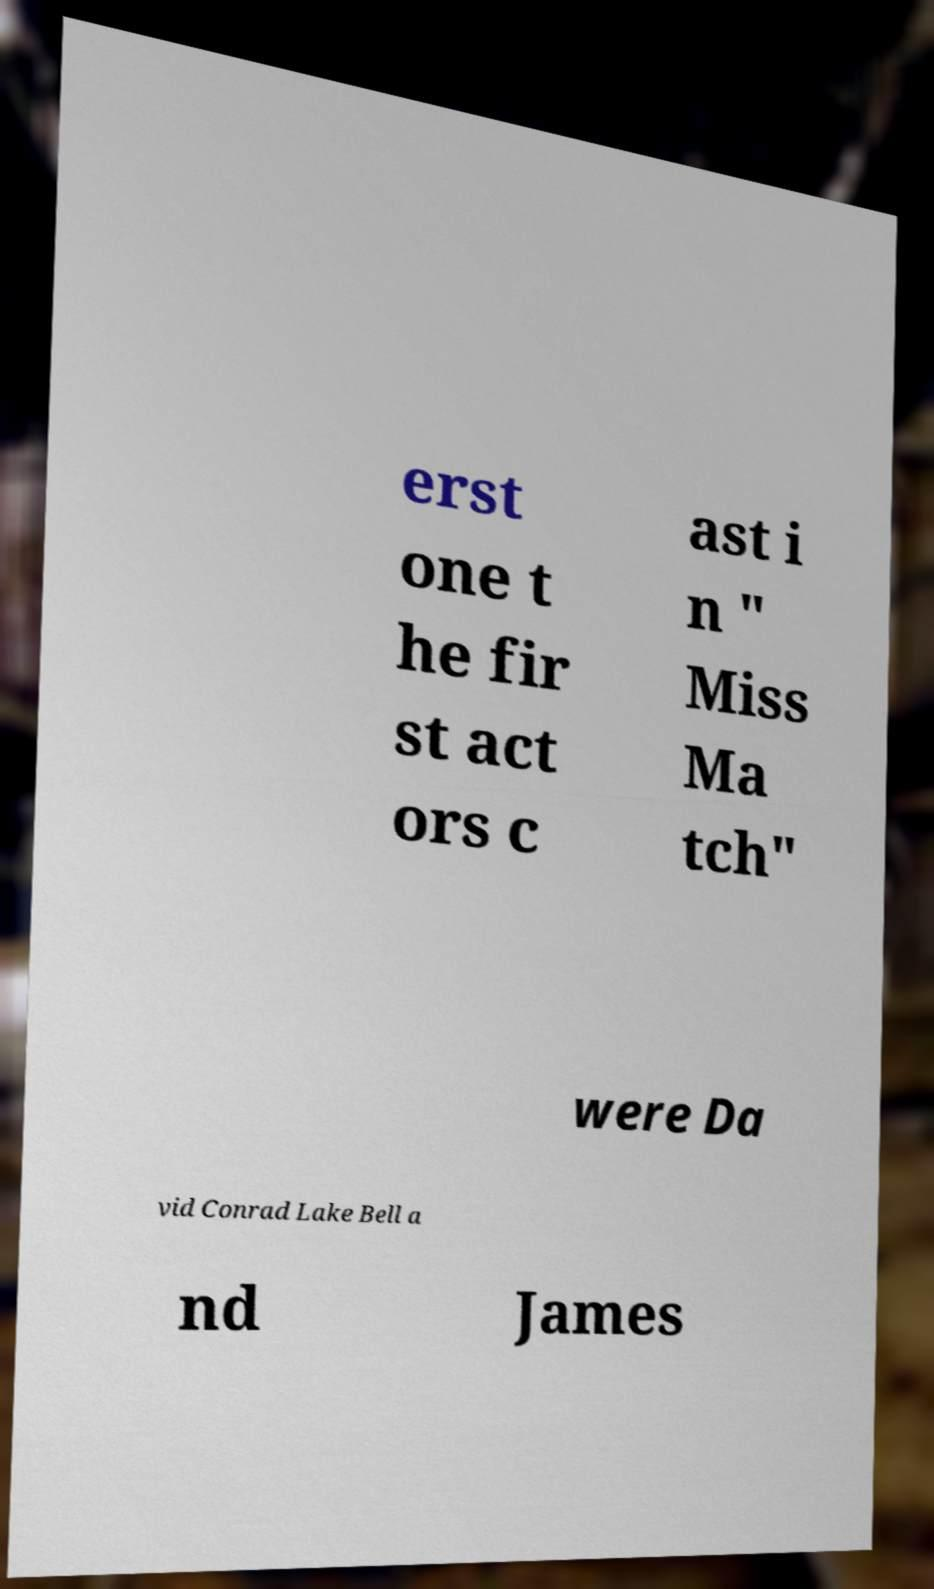Can you accurately transcribe the text from the provided image for me? erst one t he fir st act ors c ast i n " Miss Ma tch" were Da vid Conrad Lake Bell a nd James 